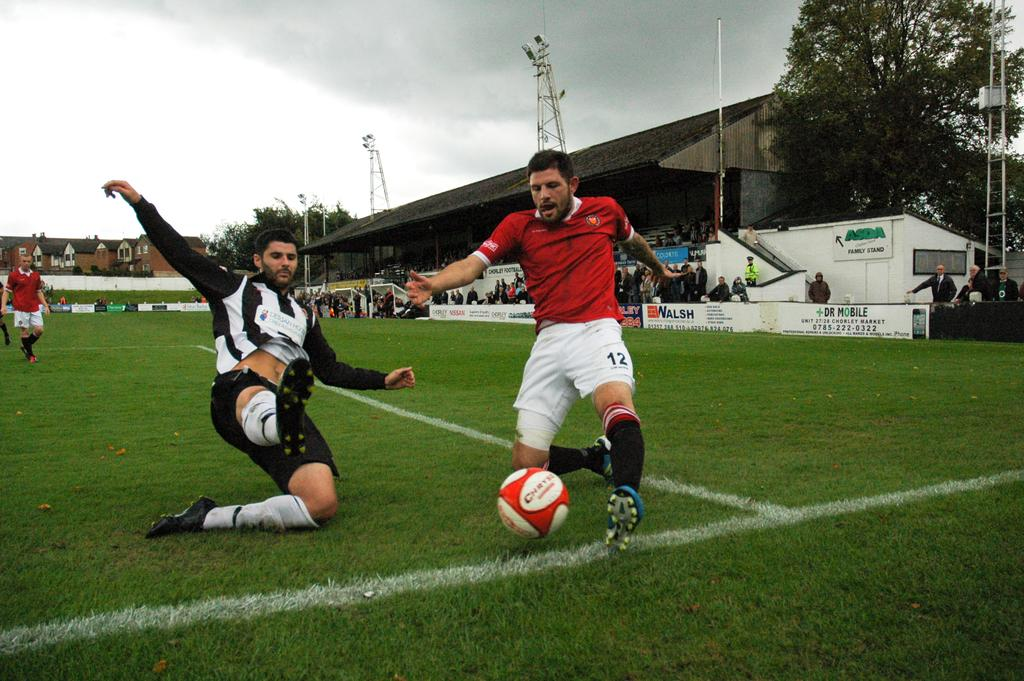<image>
Describe the image concisely. Soccer players on a field with an advertisement for Dr. Mobile on the side 